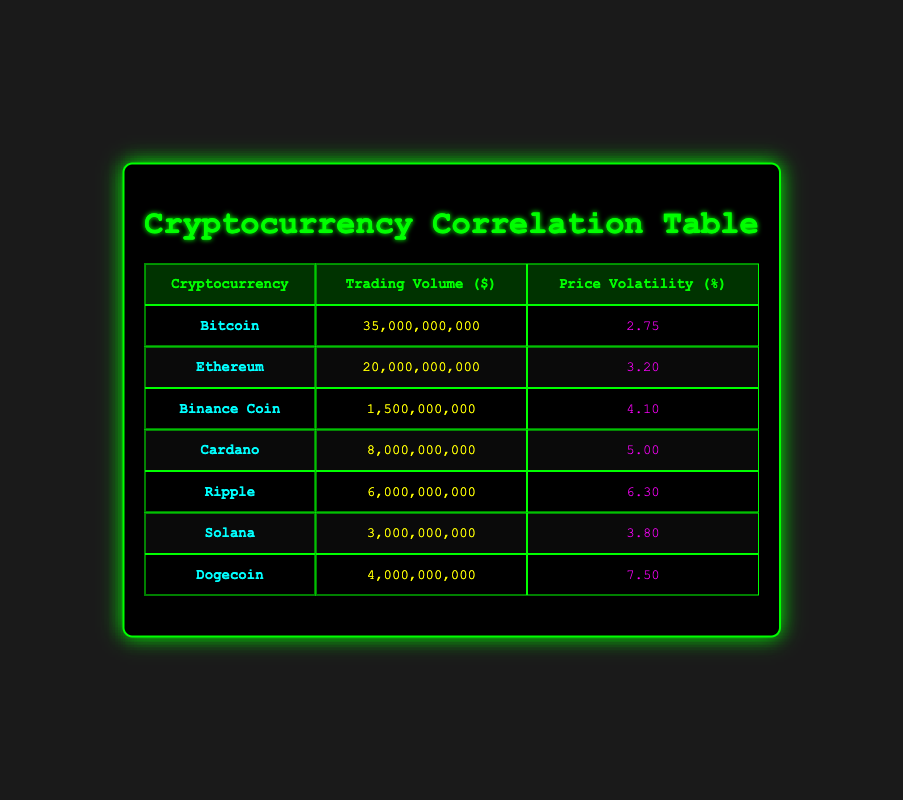What is the trading volume of Ethereum? The table shows the trading volume listed under the "Trading Volume ($)" column for Ethereum. The value is 20,000,000,000.
Answer: 20,000,000,000 Which cryptocurrency has the highest price volatility? By examining the "Price Volatility (%)" column, Dogecoin has the highest volatility at 7.50.
Answer: Dogecoin What is the total trading volume of Bitcoin, Ethereum, and Ripple combined? To calculate, sum the trading volumes: Bitcoin (35,000,000,000) + Ethereum (20,000,000,000) + Ripple (6,000,000,000) = 61,000,000,000.
Answer: 61,000,000,000 Is the price volatility of Cardano greater than that of Binance Coin? Comparing the price volatility values, Cardano has 5.00 and Binance Coin has 4.10. Since 5.00 > 4.10, the statement is true.
Answer: Yes What is the average price volatility of all cryptocurrencies listed? To find the average price volatility, sum all the values: 2.75 + 3.20 + 4.10 + 5.00 + 6.30 + 3.80 + 7.50 = 32.65. Then divide by the number of cryptocurrencies, which is 7: 32.65 / 7 = 4.66.
Answer: 4.66 Which cryptocurrency has the lowest trading volume? The table displays that Binance Coin has the lowest trading volume at 1,500,000,000.
Answer: Binance Coin Are trading volumes directly correlated with price volatility across these cryptocurrencies? A detailed analysis would involve looking at the relationship between trading volumes and price volatility. The data shows that generally, higher trading volumes don't result in lower volatility and vice versa, indicating no direct correlation.
Answer: No 